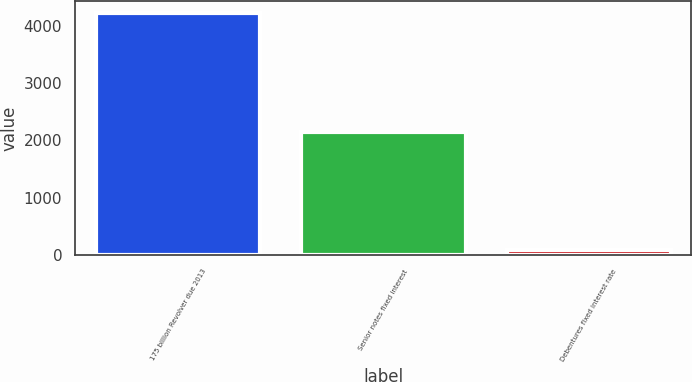<chart> <loc_0><loc_0><loc_500><loc_500><bar_chart><fcel>175 billion Revolver due 2013<fcel>Senior notes fixed interest<fcel>Debentures fixed interest rate<nl><fcel>4214.8<fcel>2153.95<fcel>93.1<nl></chart> 